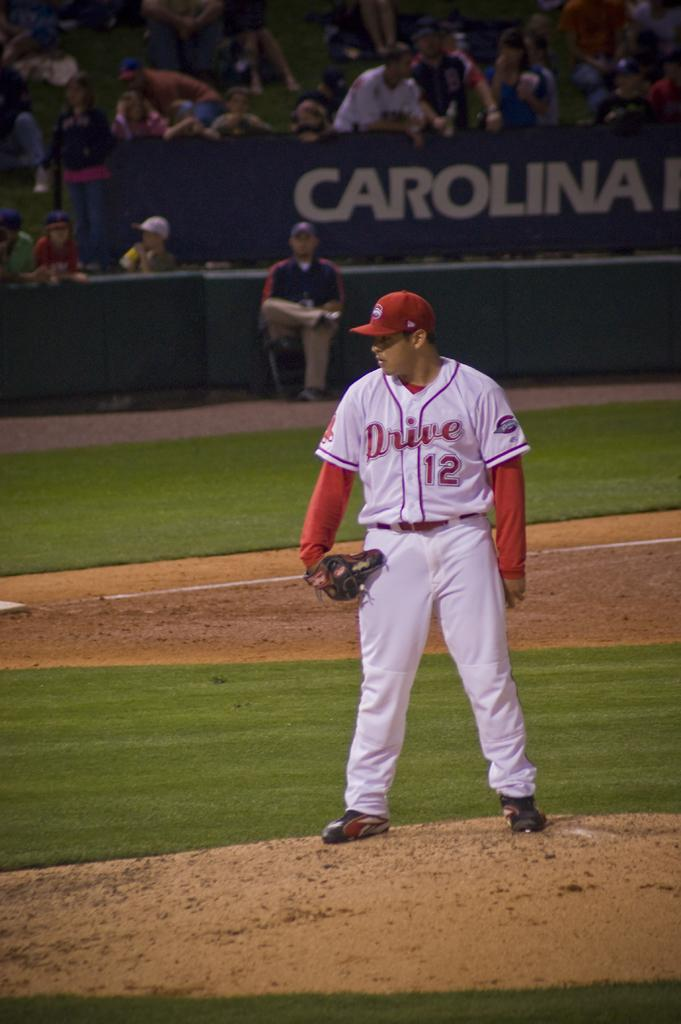<image>
Relay a brief, clear account of the picture shown. A pitcher wearing a jersey depicting Drive 12 on his jersey stands on the mound. 